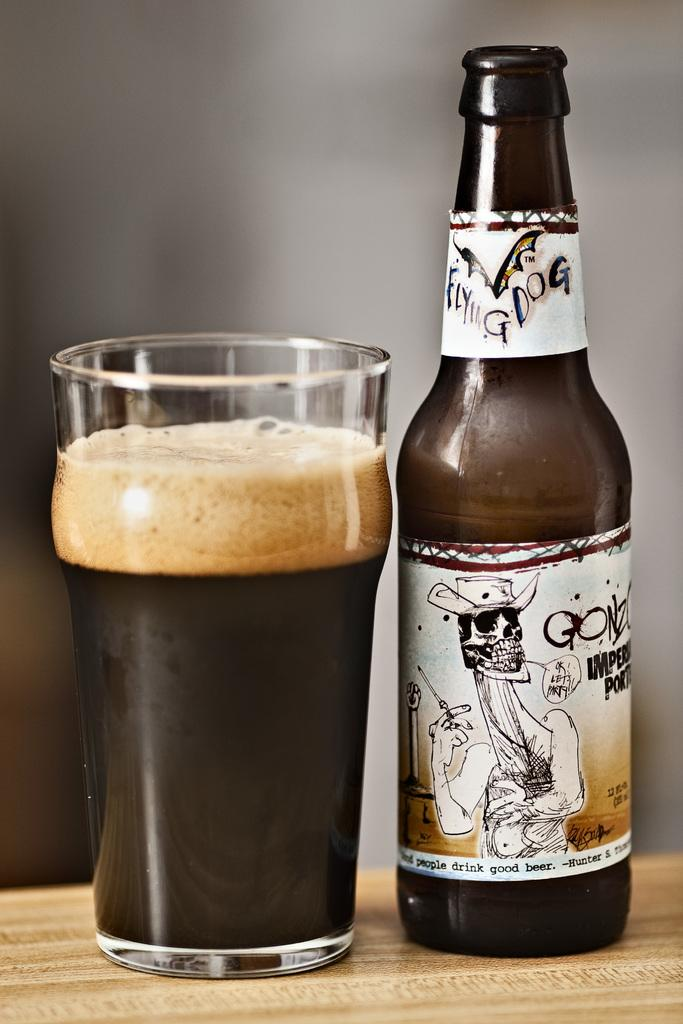Provide a one-sentence caption for the provided image. A bottle of Flying Dog beer next to a glass of beer with a thick head. 